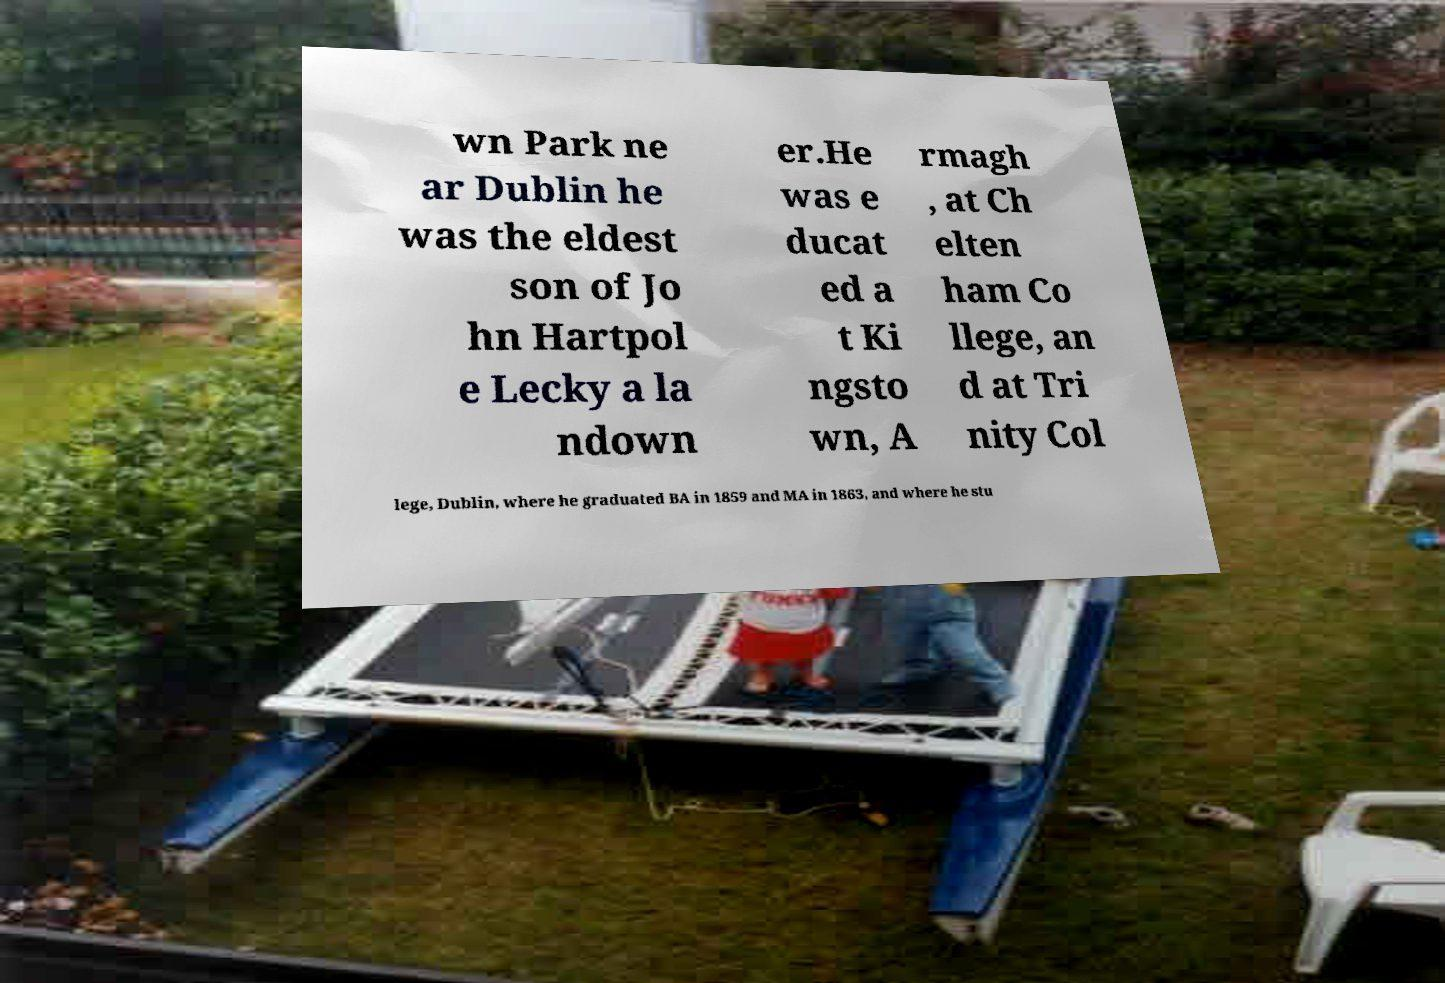Can you accurately transcribe the text from the provided image for me? wn Park ne ar Dublin he was the eldest son of Jo hn Hartpol e Lecky a la ndown er.He was e ducat ed a t Ki ngsto wn, A rmagh , at Ch elten ham Co llege, an d at Tri nity Col lege, Dublin, where he graduated BA in 1859 and MA in 1863, and where he stu 